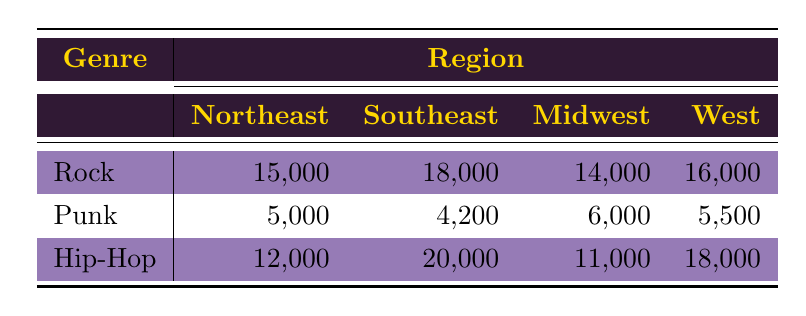What is the total attendance for Rock concerts in the Southeast region? The table shows that the attendance for Rock concerts in the Southeast region is 18,000.
Answer: 18,000 What region had the highest attendance for Hip-Hop concerts? The table lists the attendance for Hip-Hop concerts: Northeast (12,000), Southeast (20,000), Midwest (11,000), and West (18,000). The highest is 20,000 in the Southeast region.
Answer: Southeast Is the attendance for Punk concerts in the Midwest greater than that in the Northeast? The table shows 6,000 for Punk concerts in the Midwest and 5,000 in the Northeast. 6,000 is greater than 5,000, so the answer is yes.
Answer: Yes What is the average attendance for Punk concerts across all regions? The attendances for Punk concerts are 5,000 (Northeast), 4,200 (Southeast), 6,000 (Midwest), and 5,500 (West). To find the average, sum these values: 5,000 + 4,200 + 6,000 + 5,500 = 20,700. Then divide by the number of regions (4): 20,700 / 4 = 5,175.
Answer: 5,175 Which genre had the lowest attendance in the Northeast region? The Northeast region shows attendance numbers: Rock (15,000), Punk (5,000), Hip-Hop (12,000). The lowest attendance is 5,000 for Punk concerts.
Answer: Punk 